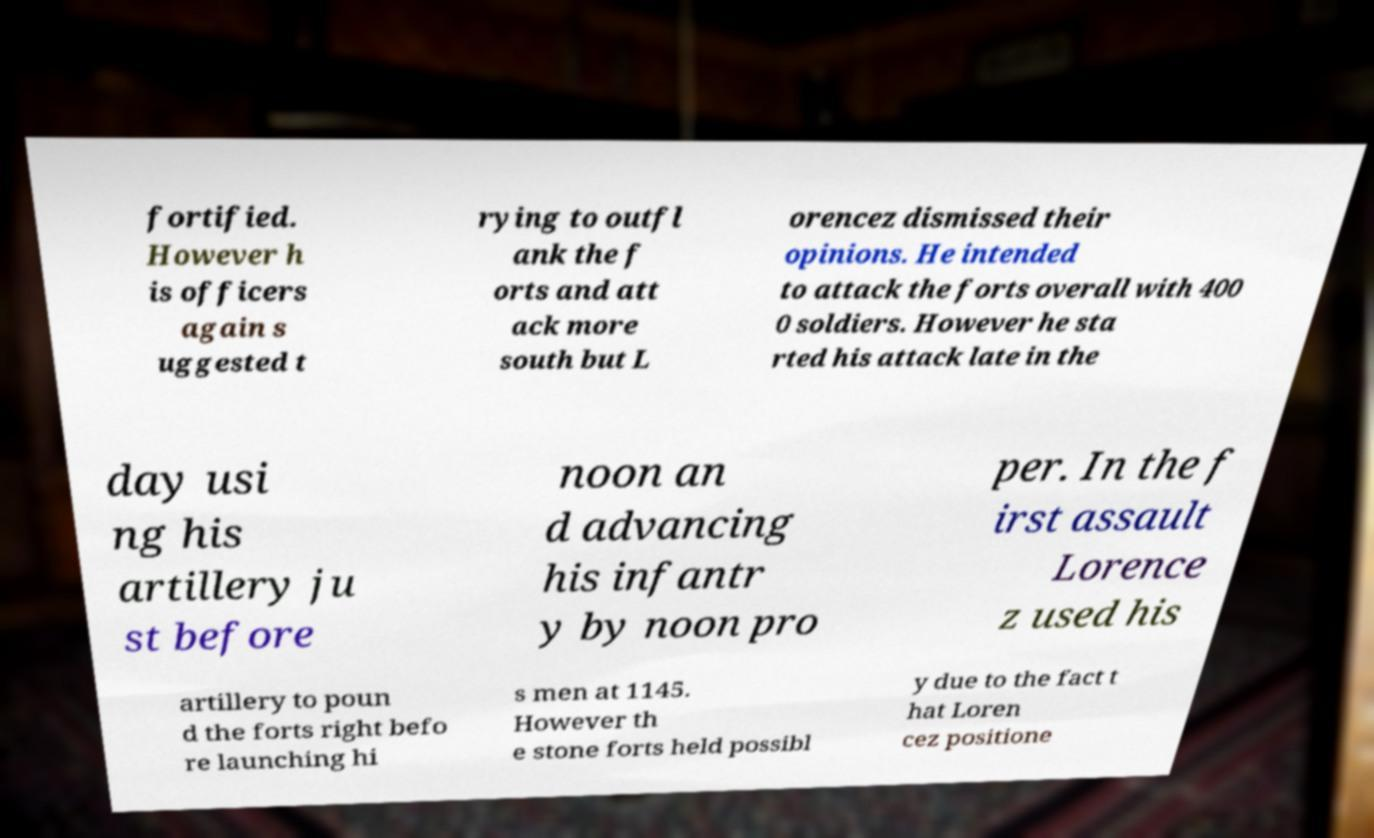Could you extract and type out the text from this image? fortified. However h is officers again s uggested t rying to outfl ank the f orts and att ack more south but L orencez dismissed their opinions. He intended to attack the forts overall with 400 0 soldiers. However he sta rted his attack late in the day usi ng his artillery ju st before noon an d advancing his infantr y by noon pro per. In the f irst assault Lorence z used his artillery to poun d the forts right befo re launching hi s men at 1145. However th e stone forts held possibl y due to the fact t hat Loren cez positione 